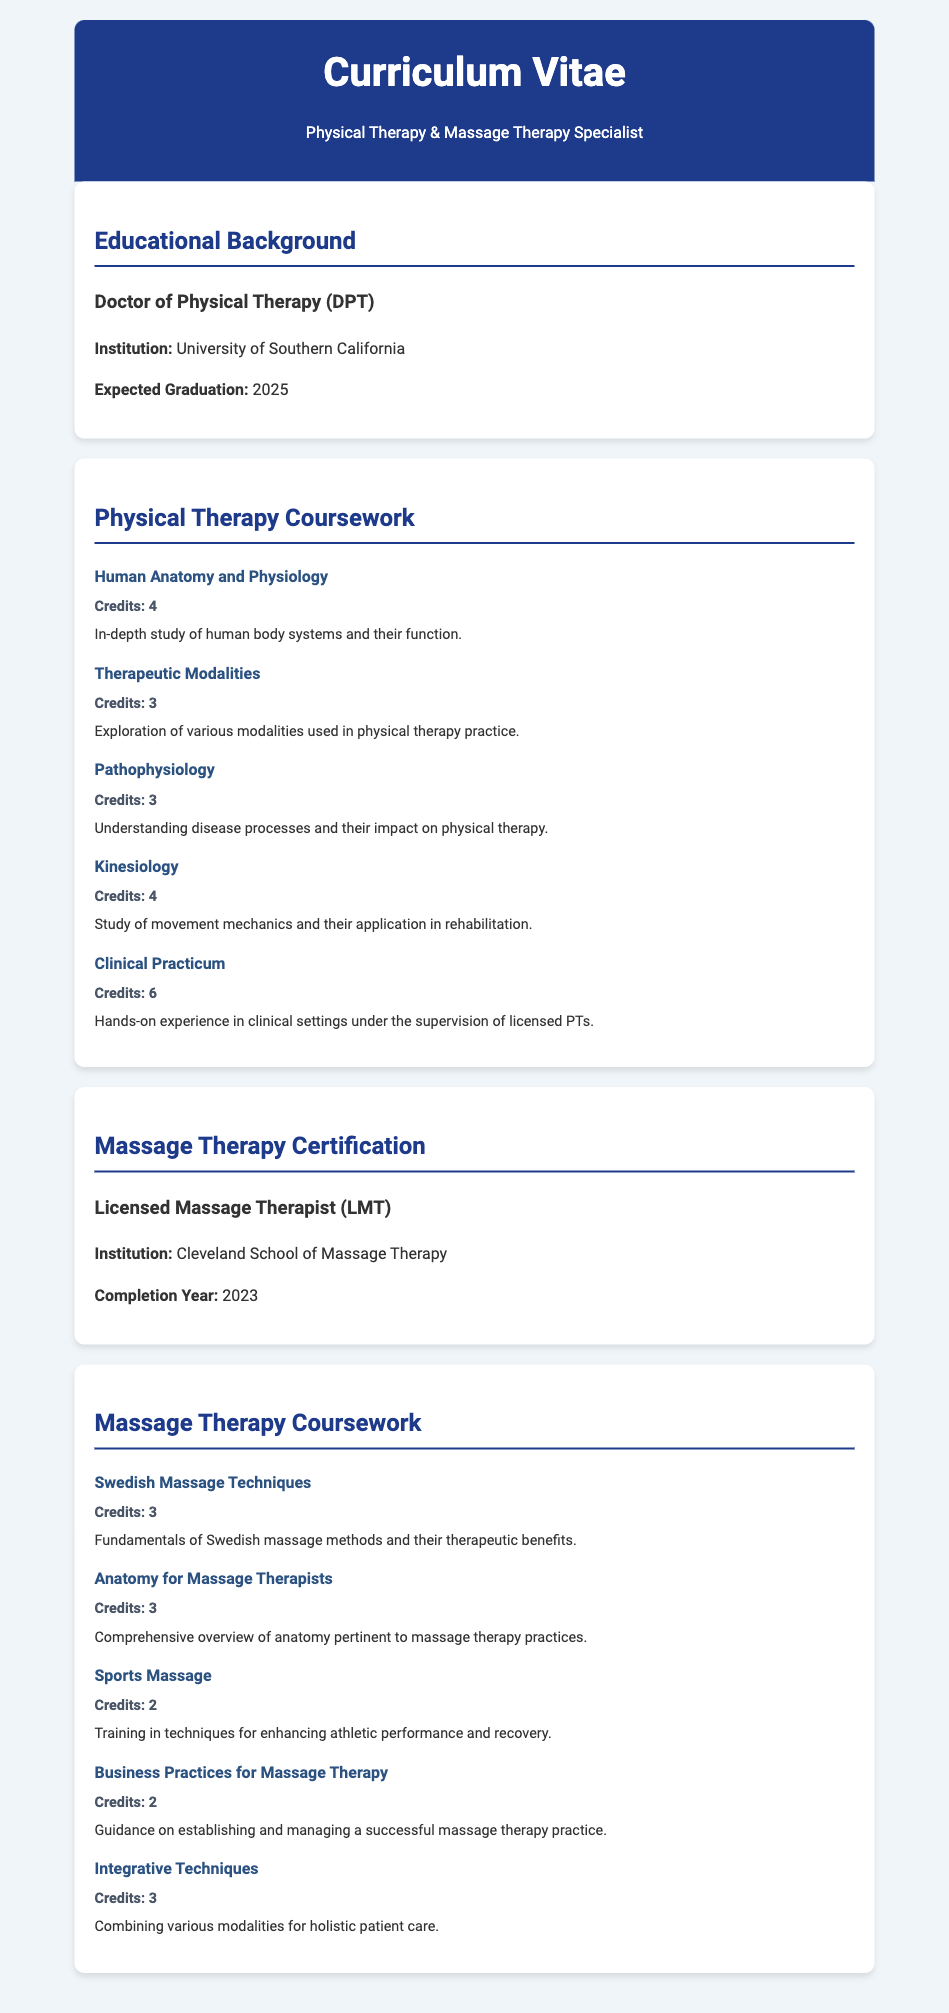What is the degree being pursued? The degree being pursued is mentioned in the educational background section.
Answer: Doctor of Physical Therapy What is the expected graduation year? The expected graduation year is specified in the educational background section.
Answer: 2025 Which institution awarded the Massage Therapy Certification? The institution for the Massage Therapy Certification is noted in the massage therapy certification section.
Answer: Cleveland School of Massage Therapy How many credits is the Clinical Practicum course? The credits for the Clinical Practicum course are provided in the physical therapy coursework section.
Answer: 6 What topic does the course "Business Practices for Massage Therapy" cover? The description of the course outlines what it addresses.
Answer: Guidance on establishing and managing a successful massage therapy practice What is the total number of credits from the Physical Therapy Coursework? The total credits from the listed courses need to be summed up from the individual credits.
Answer: 20 Which course focuses on disease processes? The course that specifically addresses disease processes is identified in the coursework list.
Answer: Pathophysiology How many courses are listed under Massage Therapy Coursework? The number of courses under the massage therapy coursework can be counted from the document.
Answer: 5 What is the focus of Kinesiology course? The course description provides information about the focus of the Kinesiology course.
Answer: Study of movement mechanics and their application in rehabilitation 